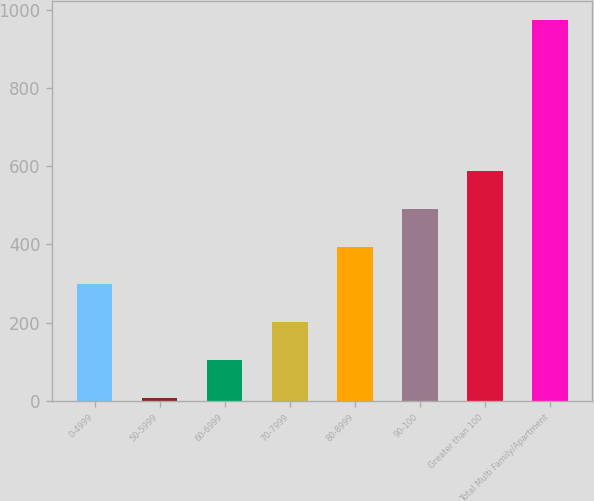<chart> <loc_0><loc_0><loc_500><loc_500><bar_chart><fcel>0-4999<fcel>50-5999<fcel>60-6999<fcel>70-7999<fcel>80-8999<fcel>90-100<fcel>Greater than 100<fcel>Total Multi Family/Apartment<nl><fcel>297.8<fcel>8<fcel>104.6<fcel>201.2<fcel>394.4<fcel>491<fcel>587.6<fcel>974<nl></chart> 